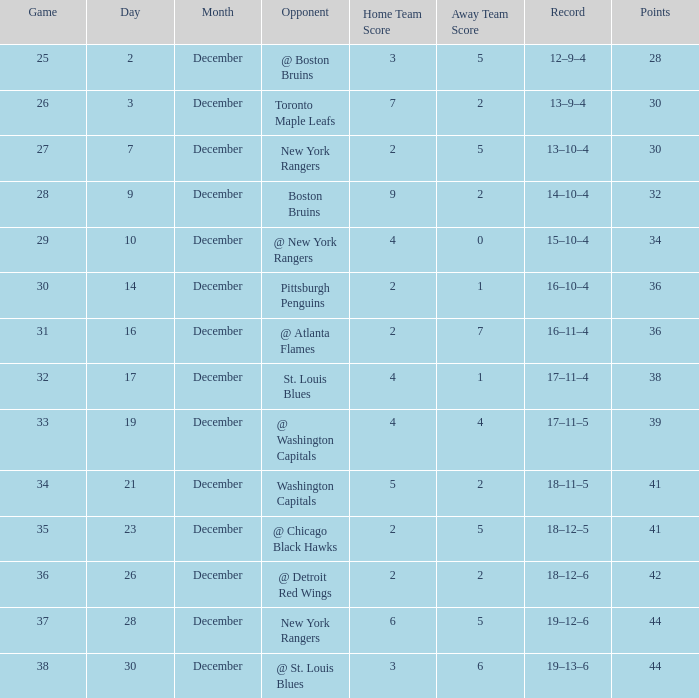Which Score has Points of 36, and a Game of 30? 2–1. 